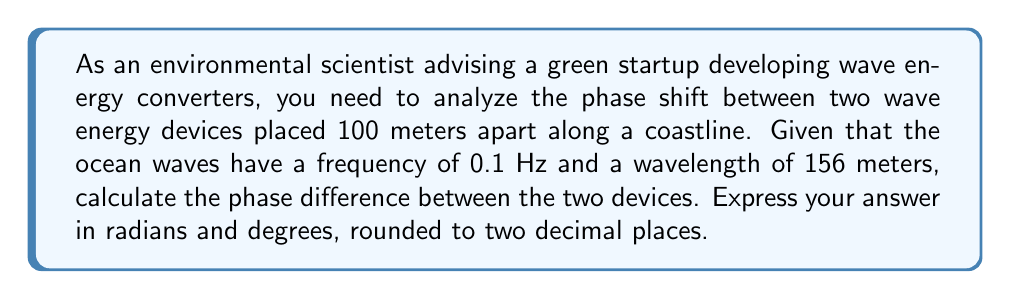Show me your answer to this math problem. To solve this problem, we need to use the concept of phase shift in wave propagation. The phase difference between two points in a wave is given by the formula:

$$\Delta \phi = \frac{2\pi \Delta x}{\lambda}$$

Where:
$\Delta \phi$ is the phase difference in radians
$\Delta x$ is the distance between the two points
$\lambda$ is the wavelength

Given:
- Distance between devices, $\Delta x = 100$ meters
- Wavelength, $\lambda = 156$ meters

Step 1: Calculate the phase difference in radians
$$\Delta \phi = \frac{2\pi \cdot 100}{156} = \frac{200\pi}{156} \approx 4.0284 \text{ radians}$$

Step 2: Convert radians to degrees
To convert radians to degrees, we use the formula:
$$\text{degrees} = \text{radians} \cdot \frac{180°}{\pi}$$

$$4.0284 \text{ radians} \cdot \frac{180°}{\pi} \approx 230.84°$$

Note: The frequency of 0.1 Hz is not directly used in this calculation but is useful information for understanding the wave characteristics and could be used in other related calculations.
Answer: The phase difference between the two wave energy devices is approximately 4.03 radians or 230.84°. 